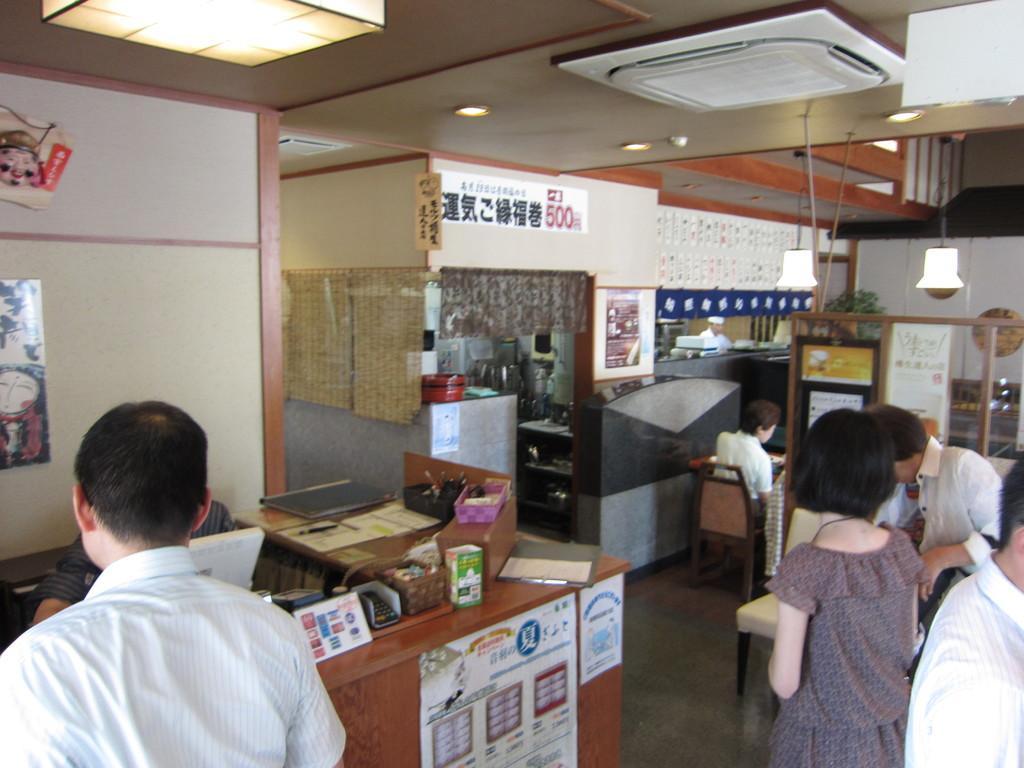Please provide a concise description of this image. At the top we can see central AC, lights, ceiling. We can see posts over a wall. These are lights. Here we can see persons sitting on a chair. This is a table and on the table we can see calculator, pens, laptop. We can see persons standing near to the table. 